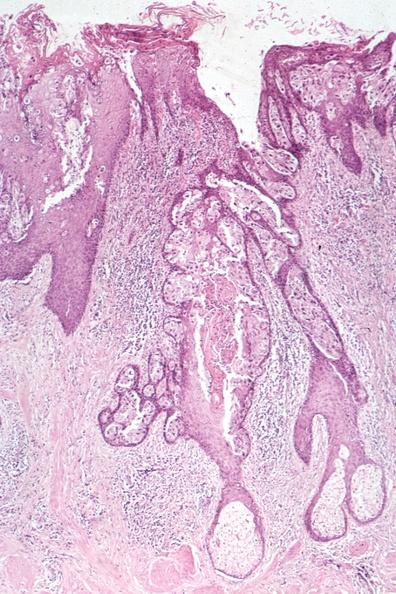what is present?
Answer the question using a single word or phrase. Carcinoma 